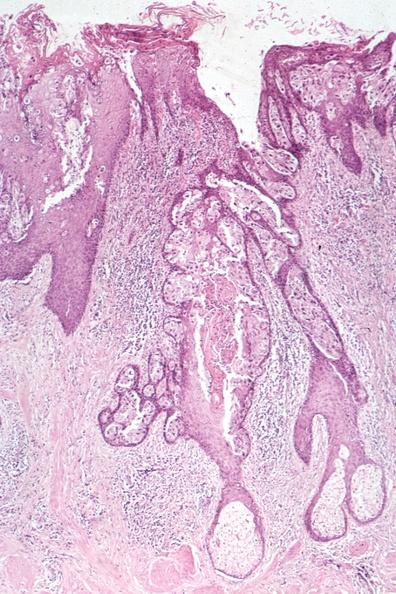what is present?
Answer the question using a single word or phrase. Carcinoma 